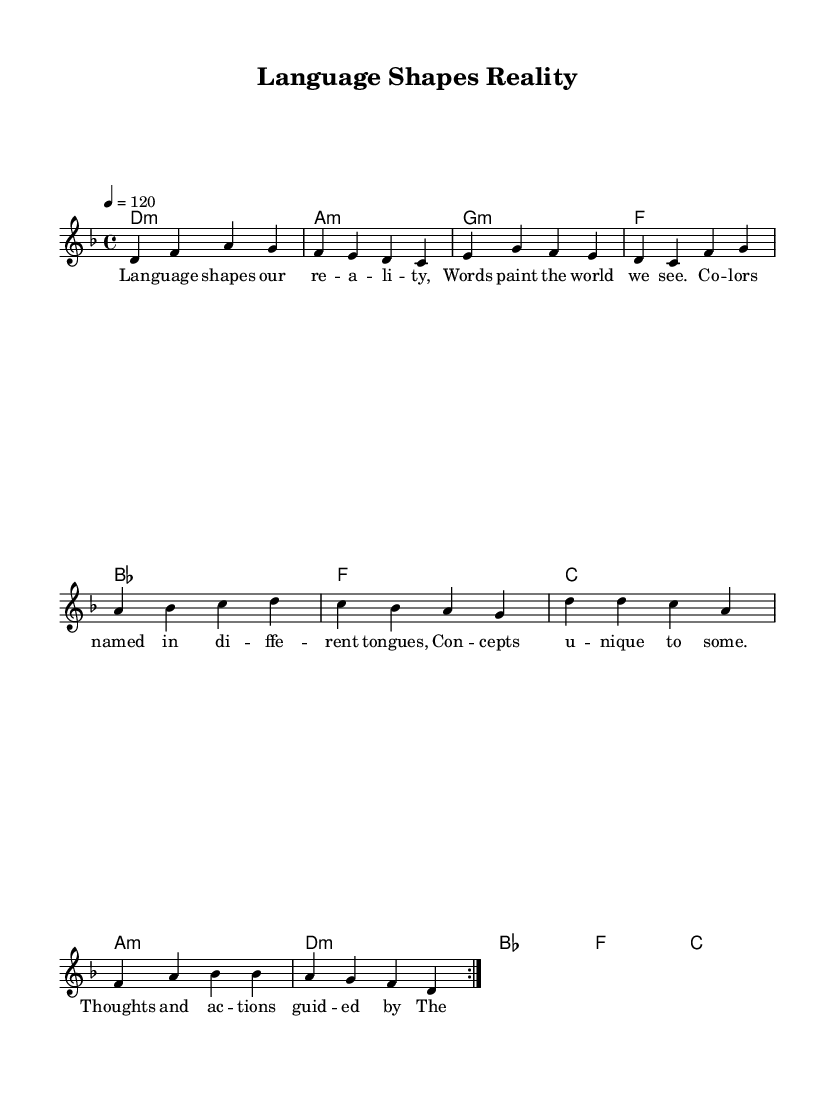What is the key signature of this music? The key signature is specified as D minor, which contains one flat, B flat. This can be identified at the beginning of the sheet music, where the key signature is notated.
Answer: D minor What is the time signature of the piece? The time signature reads as 4/4, meaning there are four beats in each measure and the quarter note gets one beat. This information is clearly indicated at the start of the sheet music.
Answer: 4/4 What is the tempo indication given in the score? The tempo indication is 120 beats per minute, which is noted just above the staff at the beginning of the piece. This indicates the speed at which the music should be played.
Answer: 120 What is the final chord of the chorus section? The final chord of the chorus is C major, evidenced by the harmonic structure shown in the harmonies section, where the last measure of the chorus concludes with a C major chord.
Answer: C How many times is the verse repeated in the structure? The verse is repeated two times as indicated by the "repeat volta" markings at the start of the verse section in the melody. This means that musicians should play the verse twice before moving on to the next section.
Answer: 2 What lyrical theme is explored in this song? The lyrics emphasize the theme of linguistic relativity, highlighting how language affects perception and thought. This central idea is evident in phrases like "Language shapes our reality" and "The power of our words."
Answer: Linguistic relativity 